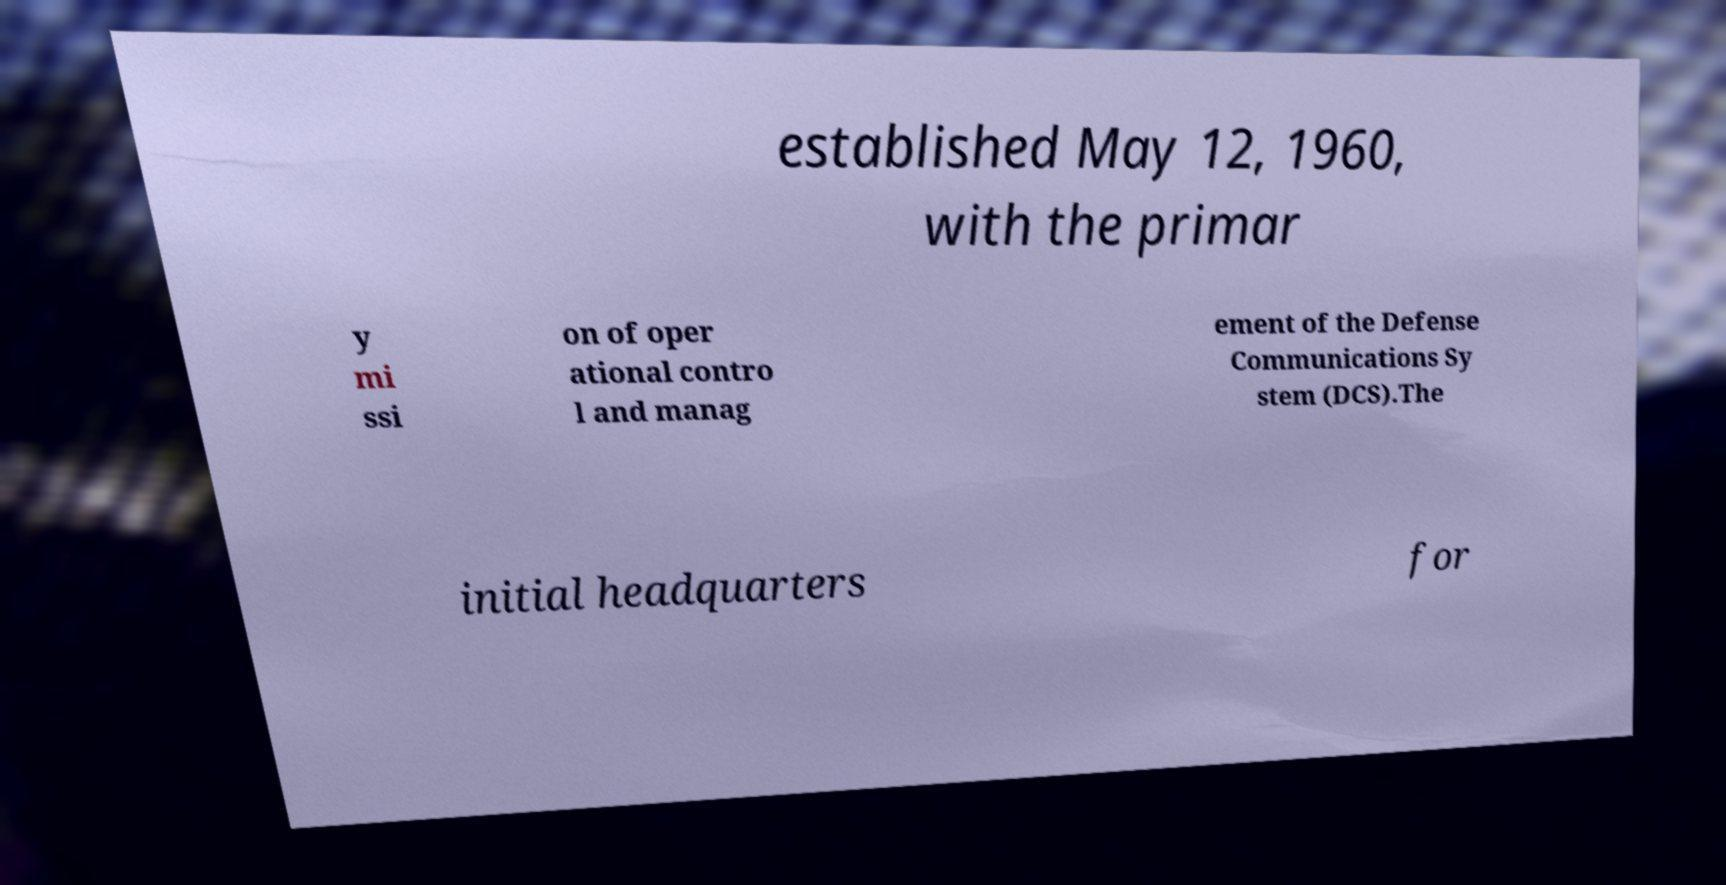What messages or text are displayed in this image? I need them in a readable, typed format. established May 12, 1960, with the primar y mi ssi on of oper ational contro l and manag ement of the Defense Communications Sy stem (DCS).The initial headquarters for 